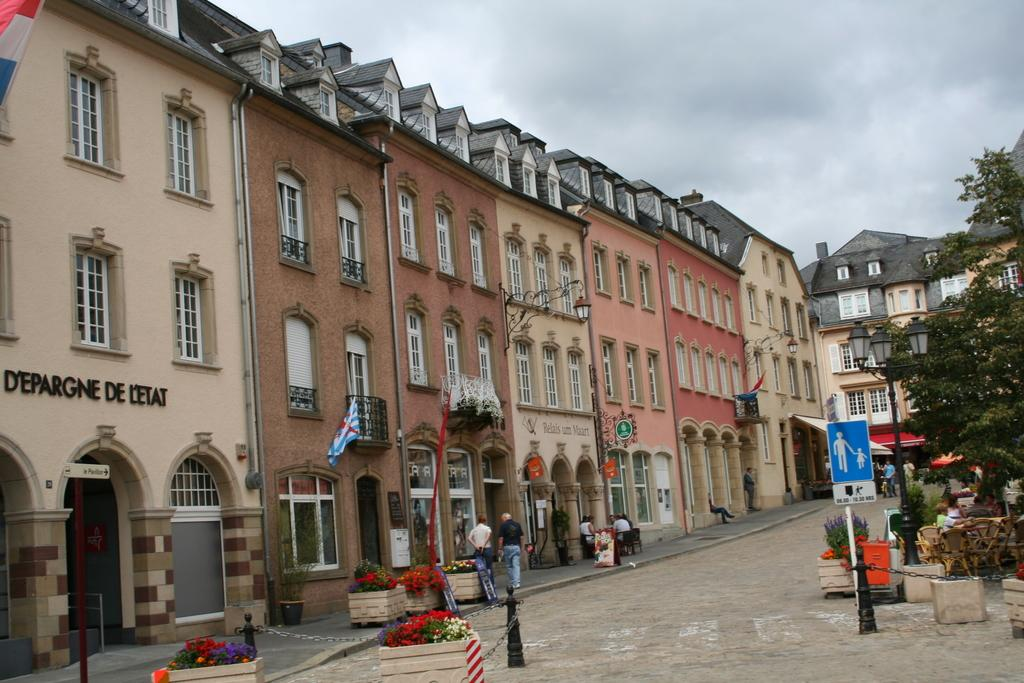What type of structures can be seen in the image? There are buildings in the image. What objects are present near the buildings? There are flower pots, windows, trees, poles, flags, and chairs in the image. Are there any living beings in the image? Yes, there are people in the image. What can be seen in the background of the image? The sky is visible in the background of the image. What type of quartz can be seen in the image? There is no quartz present in the image. How much salt is visible in the image? There is no salt visible in the image. 